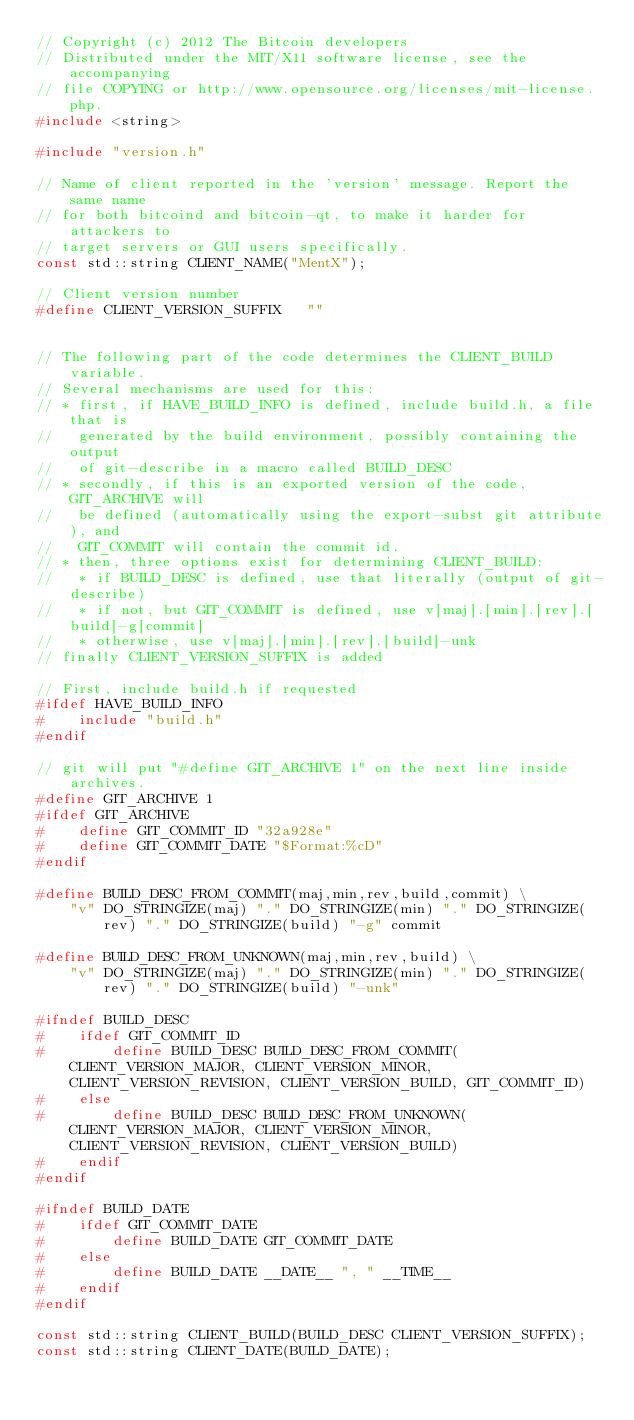<code> <loc_0><loc_0><loc_500><loc_500><_C++_>// Copyright (c) 2012 The Bitcoin developers
// Distributed under the MIT/X11 software license, see the accompanying
// file COPYING or http://www.opensource.org/licenses/mit-license.php.
#include <string>

#include "version.h"

// Name of client reported in the 'version' message. Report the same name
// for both bitcoind and bitcoin-qt, to make it harder for attackers to
// target servers or GUI users specifically.
const std::string CLIENT_NAME("MentX");

// Client version number
#define CLIENT_VERSION_SUFFIX   ""


// The following part of the code determines the CLIENT_BUILD variable.
// Several mechanisms are used for this:
// * first, if HAVE_BUILD_INFO is defined, include build.h, a file that is
//   generated by the build environment, possibly containing the output
//   of git-describe in a macro called BUILD_DESC
// * secondly, if this is an exported version of the code, GIT_ARCHIVE will
//   be defined (automatically using the export-subst git attribute), and
//   GIT_COMMIT will contain the commit id.
// * then, three options exist for determining CLIENT_BUILD:
//   * if BUILD_DESC is defined, use that literally (output of git-describe)
//   * if not, but GIT_COMMIT is defined, use v[maj].[min].[rev].[build]-g[commit]
//   * otherwise, use v[maj].[min].[rev].[build]-unk
// finally CLIENT_VERSION_SUFFIX is added

// First, include build.h if requested
#ifdef HAVE_BUILD_INFO
#    include "build.h"
#endif

// git will put "#define GIT_ARCHIVE 1" on the next line inside archives. 
#define GIT_ARCHIVE 1
#ifdef GIT_ARCHIVE
#    define GIT_COMMIT_ID "32a928e"
#    define GIT_COMMIT_DATE "$Format:%cD"
#endif

#define BUILD_DESC_FROM_COMMIT(maj,min,rev,build,commit) \
    "v" DO_STRINGIZE(maj) "." DO_STRINGIZE(min) "." DO_STRINGIZE(rev) "." DO_STRINGIZE(build) "-g" commit

#define BUILD_DESC_FROM_UNKNOWN(maj,min,rev,build) \
    "v" DO_STRINGIZE(maj) "." DO_STRINGIZE(min) "." DO_STRINGIZE(rev) "." DO_STRINGIZE(build) "-unk"

#ifndef BUILD_DESC
#    ifdef GIT_COMMIT_ID
#        define BUILD_DESC BUILD_DESC_FROM_COMMIT(CLIENT_VERSION_MAJOR, CLIENT_VERSION_MINOR, CLIENT_VERSION_REVISION, CLIENT_VERSION_BUILD, GIT_COMMIT_ID)
#    else
#        define BUILD_DESC BUILD_DESC_FROM_UNKNOWN(CLIENT_VERSION_MAJOR, CLIENT_VERSION_MINOR, CLIENT_VERSION_REVISION, CLIENT_VERSION_BUILD)
#    endif
#endif

#ifndef BUILD_DATE
#    ifdef GIT_COMMIT_DATE
#        define BUILD_DATE GIT_COMMIT_DATE
#    else
#        define BUILD_DATE __DATE__ ", " __TIME__
#    endif
#endif

const std::string CLIENT_BUILD(BUILD_DESC CLIENT_VERSION_SUFFIX);
const std::string CLIENT_DATE(BUILD_DATE);
</code> 